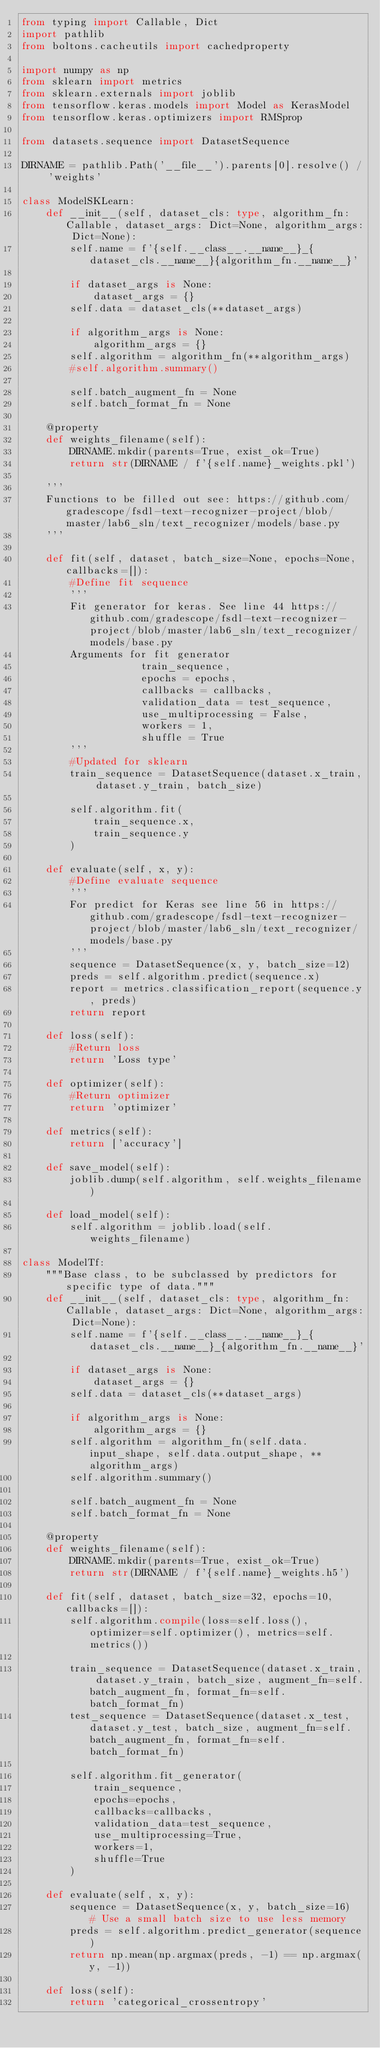Convert code to text. <code><loc_0><loc_0><loc_500><loc_500><_Python_>from typing import Callable, Dict
import pathlib
from boltons.cacheutils import cachedproperty

import numpy as np
from sklearn import metrics
from sklearn.externals import joblib
from tensorflow.keras.models import Model as KerasModel
from tensorflow.keras.optimizers import RMSprop

from datasets.sequence import DatasetSequence

DIRNAME = pathlib.Path('__file__').parents[0].resolve() / 'weights'

class ModelSKLearn:
    def __init__(self, dataset_cls: type, algorithm_fn: Callable, dataset_args: Dict=None, algorithm_args: Dict=None):
        self.name = f'{self.__class__.__name__}_{dataset_cls.__name__}{algorithm_fn.__name__}'

        if dataset_args is None:
            dataset_args = {}
        self.data = dataset_cls(**dataset_args)

        if algorithm_args is None:
            algorithm_args = {}
        self.algorithm = algorithm_fn(**algorithm_args)
        #self.algorithm.summary()

        self.batch_augment_fn = None
        self.batch_format_fn = None

    @property
    def weights_filename(self):
        DIRNAME.mkdir(parents=True, exist_ok=True)
        return str(DIRNAME / f'{self.name}_weights.pkl')

    '''
    Functions to be filled out see: https://github.com/gradescope/fsdl-text-recognizer-project/blob/master/lab6_sln/text_recognizer/models/base.py
    '''

    def fit(self, dataset, batch_size=None, epochs=None, callbacks=[]):
        #Define fit sequence
        '''
        Fit generator for keras. See line 44 https://github.com/gradescope/fsdl-text-recognizer-project/blob/master/lab6_sln/text_recognizer/models/base.py
        Arguments for fit generator
                    train_sequence,
                    epochs = epochs,
                    callbacks = callbacks,
                    validation_data = test_sequence,
                    use_multiprocessing = False,
                    workers = 1,
                    shuffle = True
        '''
        #Updated for sklearn
        train_sequence = DatasetSequence(dataset.x_train, dataset.y_train, batch_size)

        self.algorithm.fit(
            train_sequence.x,
            train_sequence.y
        )

    def evaluate(self, x, y):
        #Define evaluate sequence
        '''
        For predict for Keras see line 56 in https://github.com/gradescope/fsdl-text-recognizer-project/blob/master/lab6_sln/text_recognizer/models/base.py
        '''
        sequence = DatasetSequence(x, y, batch_size=12)
        preds = self.algorithm.predict(sequence.x)
        report = metrics.classification_report(sequence.y, preds)
        return report

    def loss(self):
        #Return loss
        return 'Loss type'

    def optimizer(self):
        #Return optimizer
        return 'optimizer'

    def metrics(self):
        return ['accuracy']

    def save_model(self):
        joblib.dump(self.algorithm, self.weights_filename)

    def load_model(self):
        self.algorithm = joblib.load(self.weights_filename)

class ModelTf:
    """Base class, to be subclassed by predictors for specific type of data."""
    def __init__(self, dataset_cls: type, algorithm_fn: Callable, dataset_args: Dict=None, algorithm_args: Dict=None):
        self.name = f'{self.__class__.__name__}_{dataset_cls.__name__}_{algorithm_fn.__name__}'

        if dataset_args is None:
            dataset_args = {}
        self.data = dataset_cls(**dataset_args)

        if algorithm_args is None:
            algorithm_args = {}
        self.algorithm = algorithm_fn(self.data.input_shape, self.data.output_shape, **algorithm_args)
        self.algorithm.summary()

        self.batch_augment_fn = None
        self.batch_format_fn = None

    @property
    def weights_filename(self):
        DIRNAME.mkdir(parents=True, exist_ok=True)
        return str(DIRNAME / f'{self.name}_weights.h5')

    def fit(self, dataset, batch_size=32, epochs=10, callbacks=[]):
        self.algorithm.compile(loss=self.loss(), optimizer=self.optimizer(), metrics=self.metrics())

        train_sequence = DatasetSequence(dataset.x_train, dataset.y_train, batch_size, augment_fn=self.batch_augment_fn, format_fn=self.batch_format_fn)
        test_sequence = DatasetSequence(dataset.x_test, dataset.y_test, batch_size, augment_fn=self.batch_augment_fn, format_fn=self.batch_format_fn)

        self.algorithm.fit_generator(
            train_sequence,
            epochs=epochs,
            callbacks=callbacks,
            validation_data=test_sequence,
            use_multiprocessing=True,
            workers=1,
            shuffle=True
        )

    def evaluate(self, x, y):
        sequence = DatasetSequence(x, y, batch_size=16)  # Use a small batch size to use less memory
        preds = self.algorithm.predict_generator(sequence)
        return np.mean(np.argmax(preds, -1) == np.argmax(y, -1))

    def loss(self):
        return 'categorical_crossentropy'
</code> 